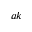Convert formula to latex. <formula><loc_0><loc_0><loc_500><loc_500>a k</formula> 